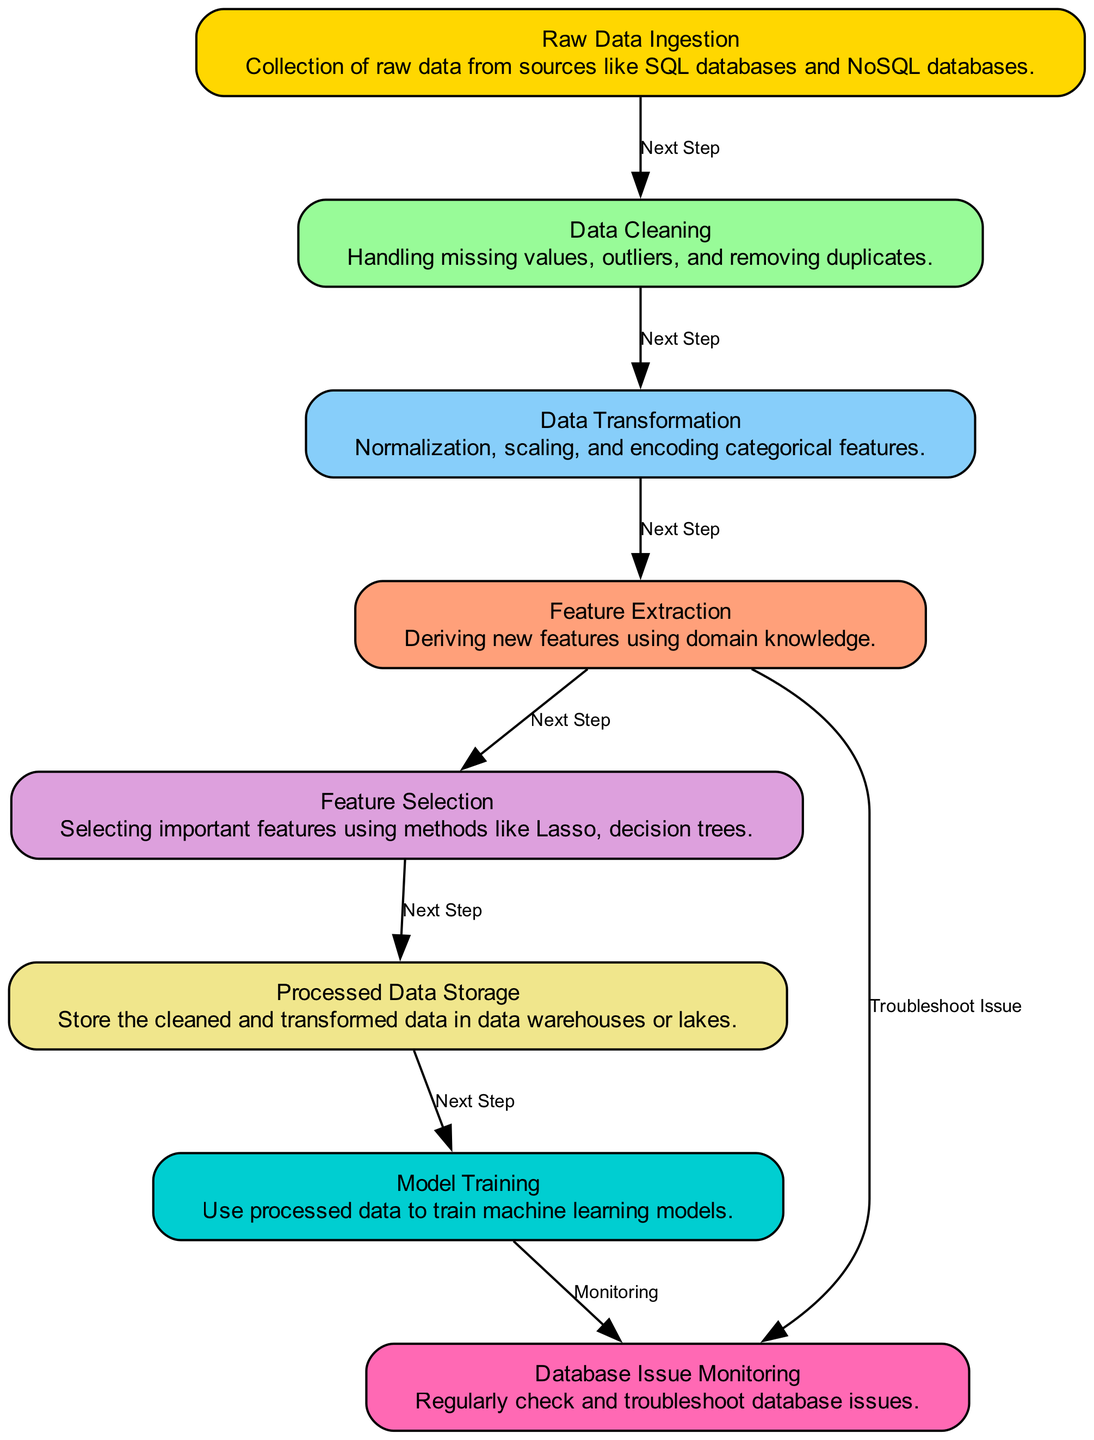What is the first step in the workflow? The first step in the workflow is labeled "Raw Data Ingestion," which is represented as the starting node in the diagram.
Answer: Raw Data Ingestion How many nodes are in the diagram? To find the total number of nodes, we can count them in the provided data. There are 8 distinct nodes listed in the data section.
Answer: 8 What is the last step before database issue monitoring? The last step before database issue monitoring is "Model Training," which is connected to "Database Issue Monitoring" by an edge labeled "Monitoring".
Answer: Model Training Which step directly transitions to "Processed Data Storage"? The step that directly transitions to "Processed Data Storage" is "Feature Selection," as indicated by an edge directly connecting these two nodes in the diagram.
Answer: Feature Selection How many direct connections lead to "Database Issue Monitoring"? "Database Issue Monitoring" has two direct connections: one from "Model Training" and one from "Feature Extraction." Therefore, we can count two edges connected to it.
Answer: 2 What action follows "Feature Extraction"? The action that follows "Feature Extraction" is "Feature Selection," indicated by a direct connection labeled "Next Step" from the former to the latter within the flow of the diagram.
Answer: Feature Selection What type of data issue is managed at the "Database Issue Monitoring" step? The "Database Issue Monitoring" step entails regularly checking and troubleshooting database issues, which focuses on ensuring the health and efficiency of the database systems used in the workflow.
Answer: Database issues Which node is responsible for handling outliers? "Data Cleaning" is the node responsible for handling outliers, as it involves tasks related to managing missing values, outliers, and duplicates listed under its description.
Answer: Data Cleaning What is derived in "Feature Extraction"? In "Feature Extraction," new features are derived using domain knowledge, as indicated in the node's description on the diagram.
Answer: New features 